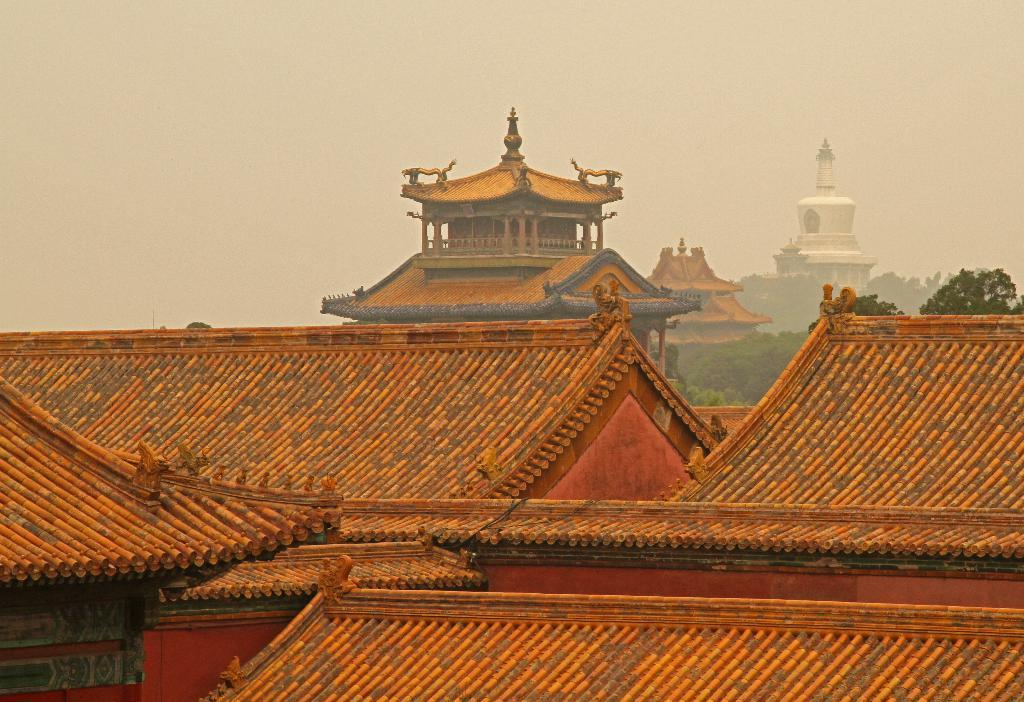What type of structures can be seen in the background of the image? There are ridges of houses in the background. How many big houses are visible in the background? There are three big houses in the background. What other natural elements can be seen in the background? There are trees in the background. What type of stem can be seen growing from the roof of one of the houses in the image? There is no stem growing from the roof of any house in the image. 